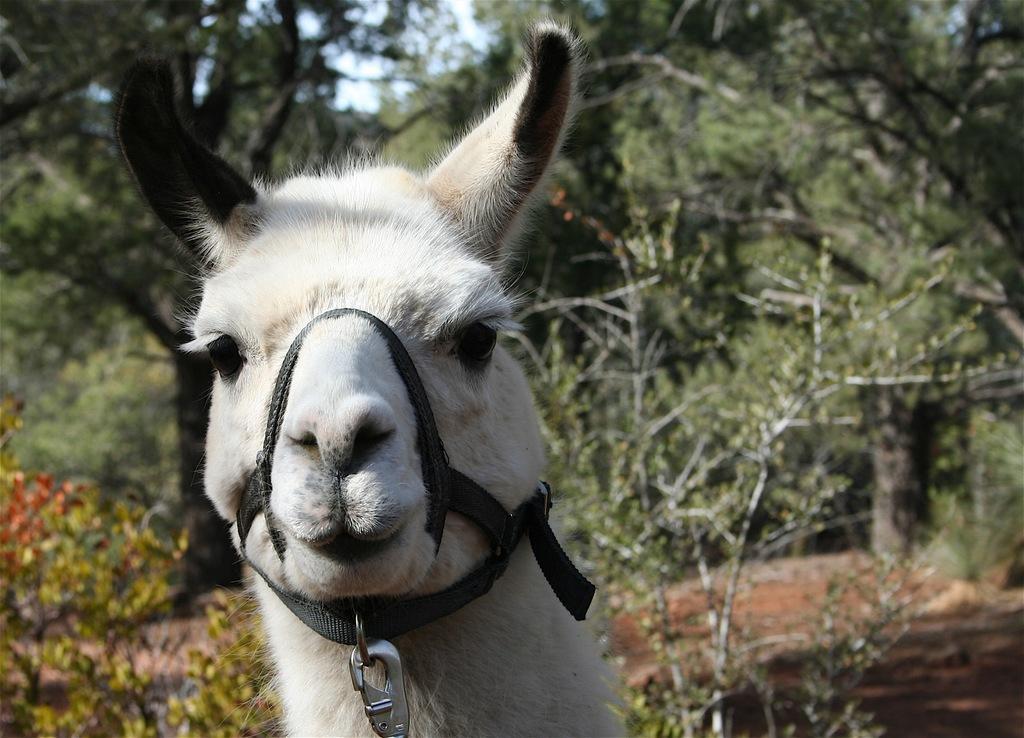Describe this image in one or two sentences. There is an animal present at the bottom of this image. We can see trees in the background. 